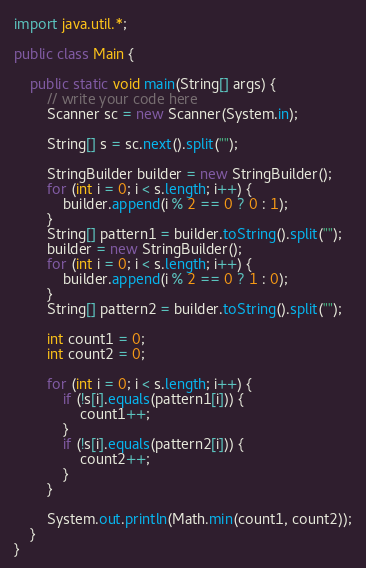<code> <loc_0><loc_0><loc_500><loc_500><_Java_>import java.util.*;

public class Main {

    public static void main(String[] args) {
        // write your code here
        Scanner sc = new Scanner(System.in);

        String[] s = sc.next().split("");

        StringBuilder builder = new StringBuilder();
        for (int i = 0; i < s.length; i++) {
            builder.append(i % 2 == 0 ? 0 : 1);
        }
        String[] pattern1 = builder.toString().split("");
        builder = new StringBuilder();
        for (int i = 0; i < s.length; i++) {
            builder.append(i % 2 == 0 ? 1 : 0);
        }
        String[] pattern2 = builder.toString().split("");

        int count1 = 0;
        int count2 = 0;

        for (int i = 0; i < s.length; i++) {
            if (!s[i].equals(pattern1[i])) {
                count1++;
            }
            if (!s[i].equals(pattern2[i])) {
                count2++;
            }
        }

        System.out.println(Math.min(count1, count2));
    }
}</code> 